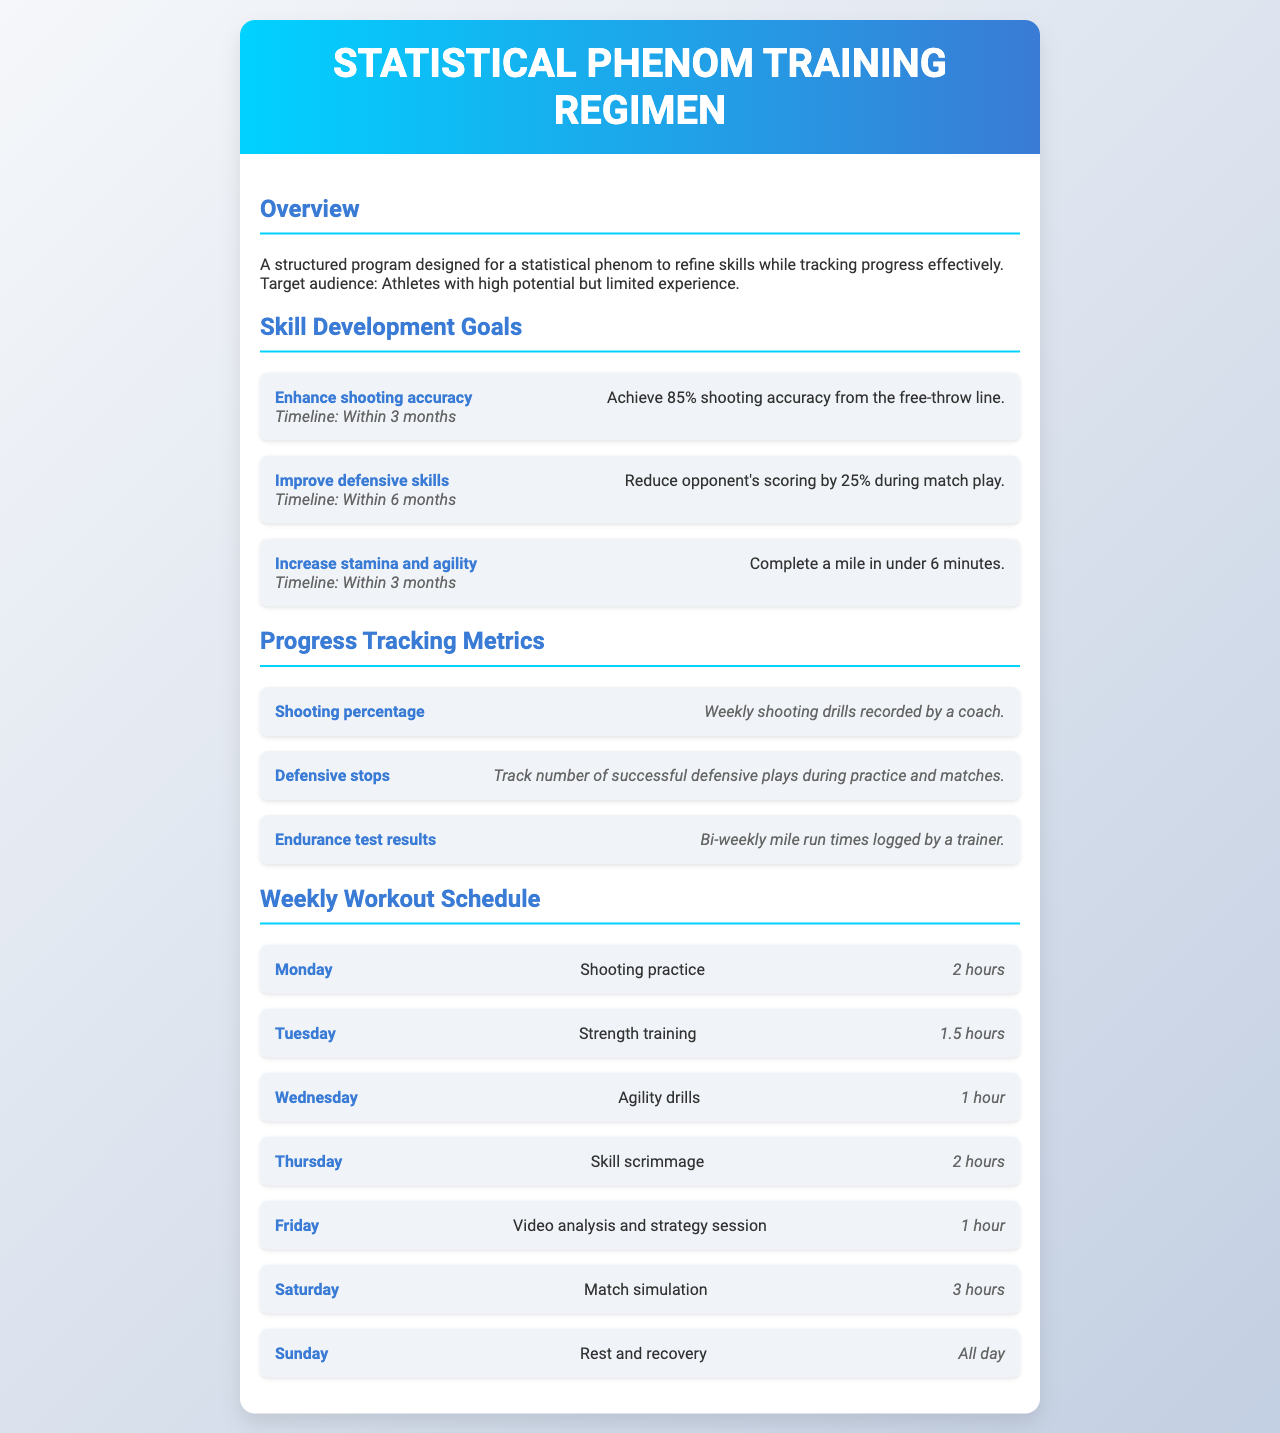What is the target shooting accuracy goal? The goal is to achieve 85% shooting accuracy from the free-throw line as stated in the skill development goals section.
Answer: 85% How long is the weekly shooting practice scheduled for? The schedule specifies that shooting practice is set for 2 hours on Monday.
Answer: 2 hours What is the timeline for improving defensive skills? The timeline for reducing opponent's scoring by 25% during match play is within 6 months.
Answer: Within 6 months How often are endurance test results logged? The document mentions that endurance test results are logged bi-weekly by a trainer.
Answer: Bi-weekly What type of training is scheduled for Tuesday? The workout schedule on Tuesday includes strength training.
Answer: Strength training How many hours are allocated for match simulation on Saturday? According to the weekly workout schedule, match simulation is allocated 3 hours on Saturday.
Answer: 3 hours What is the focus of the Friday workout session? The focus of the Friday session is on video analysis and strategy.
Answer: Video analysis and strategy session Which skill is aimed to be improved alongside stamina and agility? The goal is to enhance shooting accuracy while improving stamina and agility.
Answer: Shooting accuracy What is one method for tracking shooting percentage? The shooting percentage is tracked through weekly shooting drills recorded by a coach.
Answer: Weekly shooting drills What day is designated for rest and recovery? The day set for rest and recovery is Sunday.
Answer: Sunday 